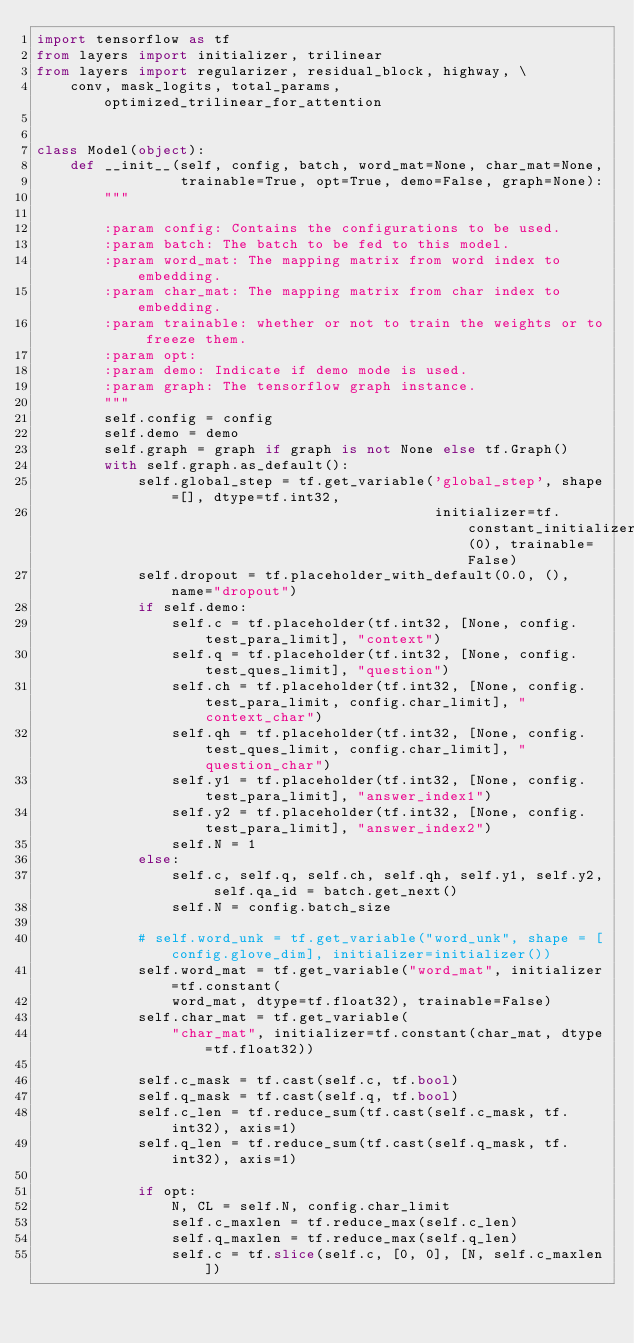<code> <loc_0><loc_0><loc_500><loc_500><_Python_>import tensorflow as tf
from layers import initializer, trilinear
from layers import regularizer, residual_block, highway, \
    conv, mask_logits, total_params, optimized_trilinear_for_attention


class Model(object):
    def __init__(self, config, batch, word_mat=None, char_mat=None,
                 trainable=True, opt=True, demo=False, graph=None):
        """

        :param config: Contains the configurations to be used.
        :param batch: The batch to be fed to this model.
        :param word_mat: The mapping matrix from word index to embedding.
        :param char_mat: The mapping matrix from char index to embedding.
        :param trainable: whether or not to train the weights or to freeze them.
        :param opt:
        :param demo: Indicate if demo mode is used.
        :param graph: The tensorflow graph instance.
        """
        self.config = config
        self.demo = demo
        self.graph = graph if graph is not None else tf.Graph()
        with self.graph.as_default():
            self.global_step = tf.get_variable('global_step', shape=[], dtype=tf.int32,
                                               initializer=tf.constant_initializer(0), trainable=False)
            self.dropout = tf.placeholder_with_default(0.0, (), name="dropout")
            if self.demo:
                self.c = tf.placeholder(tf.int32, [None, config.test_para_limit], "context")
                self.q = tf.placeholder(tf.int32, [None, config.test_ques_limit], "question")
                self.ch = tf.placeholder(tf.int32, [None, config.test_para_limit, config.char_limit], "context_char")
                self.qh = tf.placeholder(tf.int32, [None, config.test_ques_limit, config.char_limit], "question_char")
                self.y1 = tf.placeholder(tf.int32, [None, config.test_para_limit], "answer_index1")
                self.y2 = tf.placeholder(tf.int32, [None, config.test_para_limit], "answer_index2")
                self.N = 1
            else:
                self.c, self.q, self.ch, self.qh, self.y1, self.y2, self.qa_id = batch.get_next()
                self.N = config.batch_size

            # self.word_unk = tf.get_variable("word_unk", shape = [config.glove_dim], initializer=initializer())
            self.word_mat = tf.get_variable("word_mat", initializer=tf.constant(
                word_mat, dtype=tf.float32), trainable=False)
            self.char_mat = tf.get_variable(
                "char_mat", initializer=tf.constant(char_mat, dtype=tf.float32))

            self.c_mask = tf.cast(self.c, tf.bool)
            self.q_mask = tf.cast(self.q, tf.bool)
            self.c_len = tf.reduce_sum(tf.cast(self.c_mask, tf.int32), axis=1)
            self.q_len = tf.reduce_sum(tf.cast(self.q_mask, tf.int32), axis=1)

            if opt:
                N, CL = self.N, config.char_limit
                self.c_maxlen = tf.reduce_max(self.c_len)
                self.q_maxlen = tf.reduce_max(self.q_len)
                self.c = tf.slice(self.c, [0, 0], [N, self.c_maxlen])</code> 